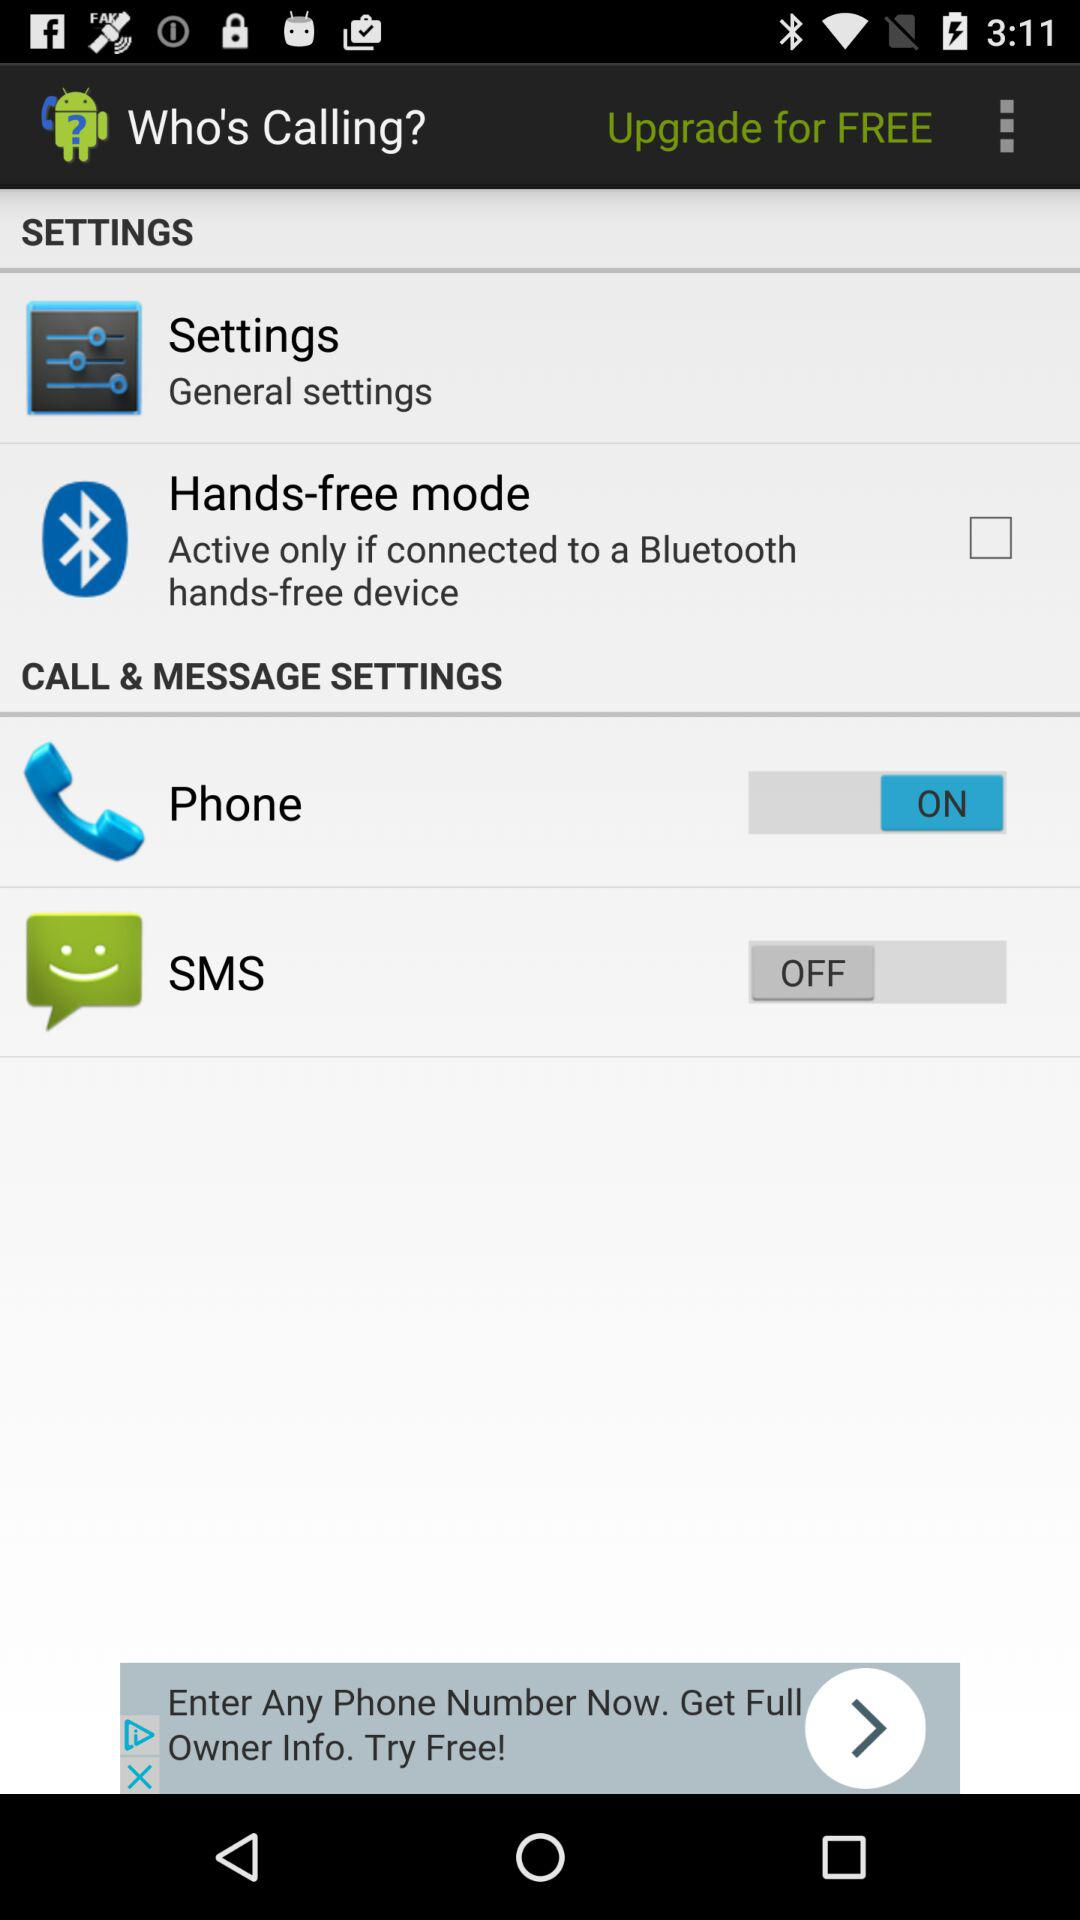What is the status of "SMS"? The status is "off". 